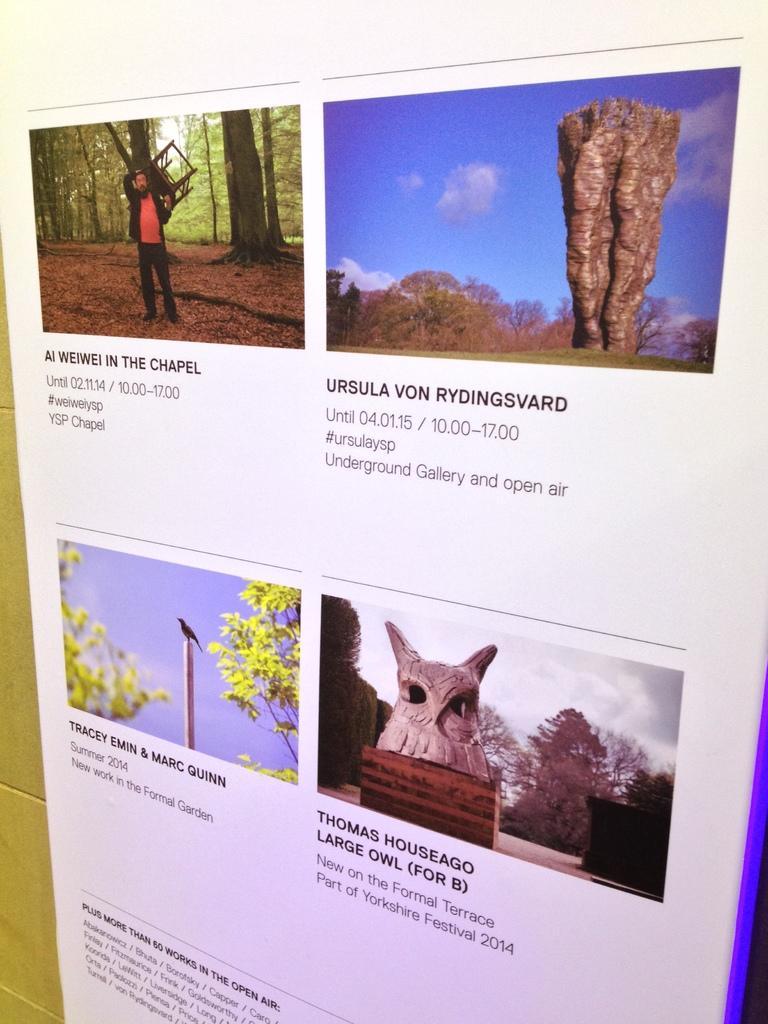Can you describe this image briefly? In this image there is a display board on the wall with photographs and text on it. 